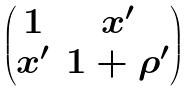<formula> <loc_0><loc_0><loc_500><loc_500>\begin{pmatrix} 1 & x ^ { \prime } \\ x ^ { \prime } & 1 + \rho ^ { \prime } \end{pmatrix}</formula> 